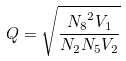<formula> <loc_0><loc_0><loc_500><loc_500>Q = \sqrt { \frac { { N _ { 8 } } ^ { 2 } V _ { 1 } } { N _ { 2 } N _ { 5 } V _ { 2 } } }</formula> 